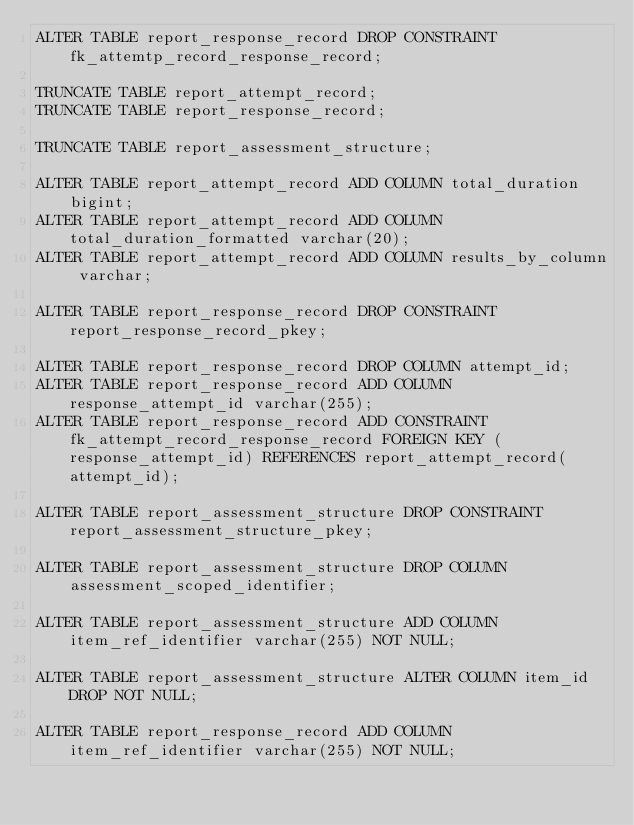Convert code to text. <code><loc_0><loc_0><loc_500><loc_500><_SQL_>ALTER TABLE report_response_record DROP CONSTRAINT fk_attemtp_record_response_record;

TRUNCATE TABLE report_attempt_record;
TRUNCATE TABLE report_response_record;

TRUNCATE TABLE report_assessment_structure;

ALTER TABLE report_attempt_record ADD COLUMN total_duration bigint;
ALTER TABLE report_attempt_record ADD COLUMN total_duration_formatted varchar(20);
ALTER TABLE report_attempt_record ADD COLUMN results_by_column varchar;

ALTER TABLE report_response_record DROP CONSTRAINT report_response_record_pkey;

ALTER TABLE report_response_record DROP COLUMN attempt_id;
ALTER TABLE report_response_record ADD COLUMN response_attempt_id varchar(255);
ALTER TABLE report_response_record ADD CONSTRAINT fk_attempt_record_response_record FOREIGN KEY (response_attempt_id) REFERENCES report_attempt_record(attempt_id);

ALTER TABLE report_assessment_structure DROP CONSTRAINT report_assessment_structure_pkey;

ALTER TABLE report_assessment_structure DROP COLUMN assessment_scoped_identifier;

ALTER TABLE report_assessment_structure ADD COLUMN item_ref_identifier varchar(255) NOT NULL;

ALTER TABLE report_assessment_structure ALTER COLUMN item_id DROP NOT NULL;

ALTER TABLE report_response_record ADD COLUMN item_ref_identifier varchar(255) NOT NULL;</code> 